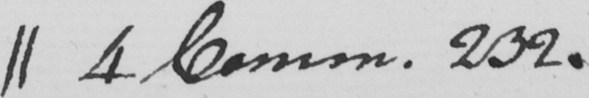What is written in this line of handwriting? || 4 Common . 232 . 